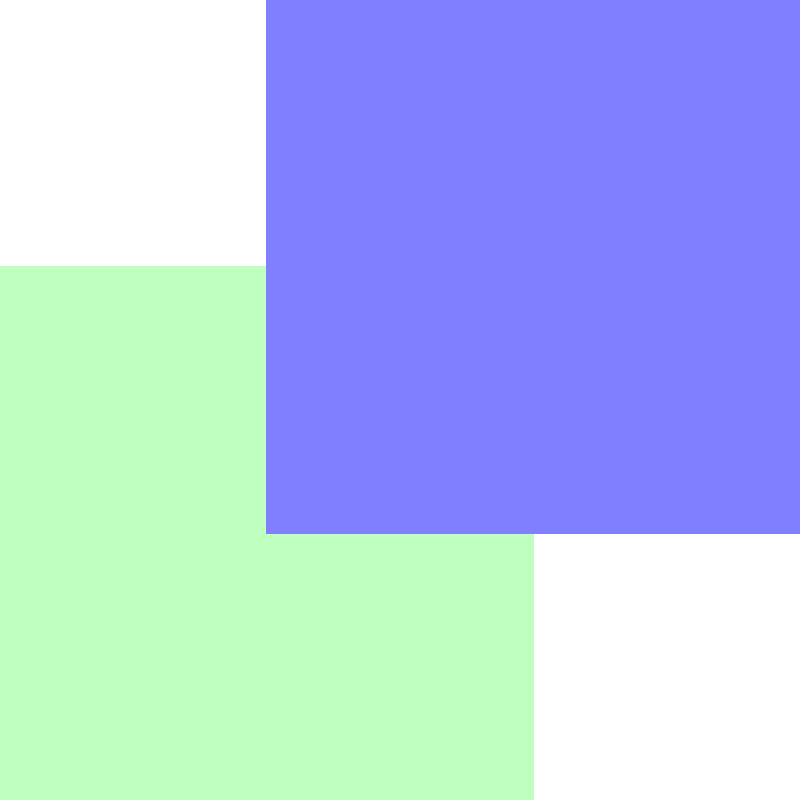In quilling, three paper strips A, B, and C are interlocked as shown in the diagram. Each strip can be rotated 90° clockwise, represented by the operation $r$. Define the group $G = \{e, r, r^2, r^3\}$, where $e$ is the identity operation. If we apply the operation $r^2$ to strip A, followed by $r^3$ to strip B, and finally $r$ to strip C, what is the resulting group element when these operations are combined? Let's approach this step-by-step:

1) First, we need to understand that the group $G = \{e, r, r^2, r^3\}$ is isomorphic to the cyclic group $C_4$, where:
   $e$ represents no rotation (identity)
   $r$ represents a 90° clockwise rotation
   $r^2$ represents a 180° rotation
   $r^3$ represents a 270° clockwise rotation (or 90° counterclockwise)

2) Now, let's apply the operations in order:
   - Apply $r^2$ to strip A: This is equivalent to applying $r^2$ to the whole system
   - Apply $r^3$ to strip B: This is equivalent to applying $r^3$ to the whole system
   - Apply $r$ to strip C: This is equivalent to applying $r$ to the whole system

3) To find the combined effect, we multiply these operations in the order they were applied:
   $r^2 * r^3 * r$

4) Using the properties of cyclic groups:
   $r^2 * r^3 * r = r^{2+3+1} = r^6$

5) In the group $G$, we can simplify this further:
   $r^6 = r^{6 \bmod 4} = r^2$

Therefore, the final result of applying these operations in sequence is equivalent to $r^2$, which represents a 180° rotation of the entire system.
Answer: $r^2$ 